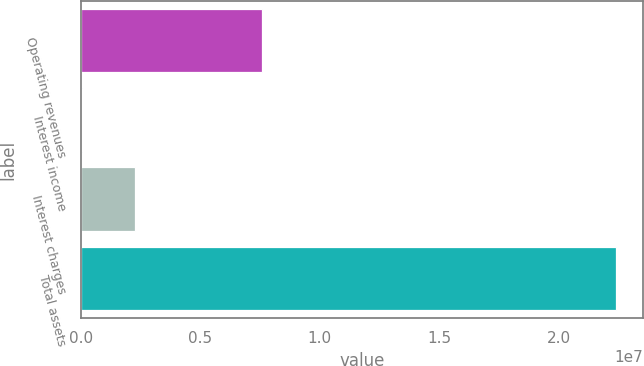Convert chart to OTSL. <chart><loc_0><loc_0><loc_500><loc_500><bar_chart><fcel>Operating revenues<fcel>Interest income<fcel>Interest charges<fcel>Total assets<nl><fcel>7.58486e+06<fcel>43035<fcel>2.27896e+06<fcel>2.24023e+07<nl></chart> 